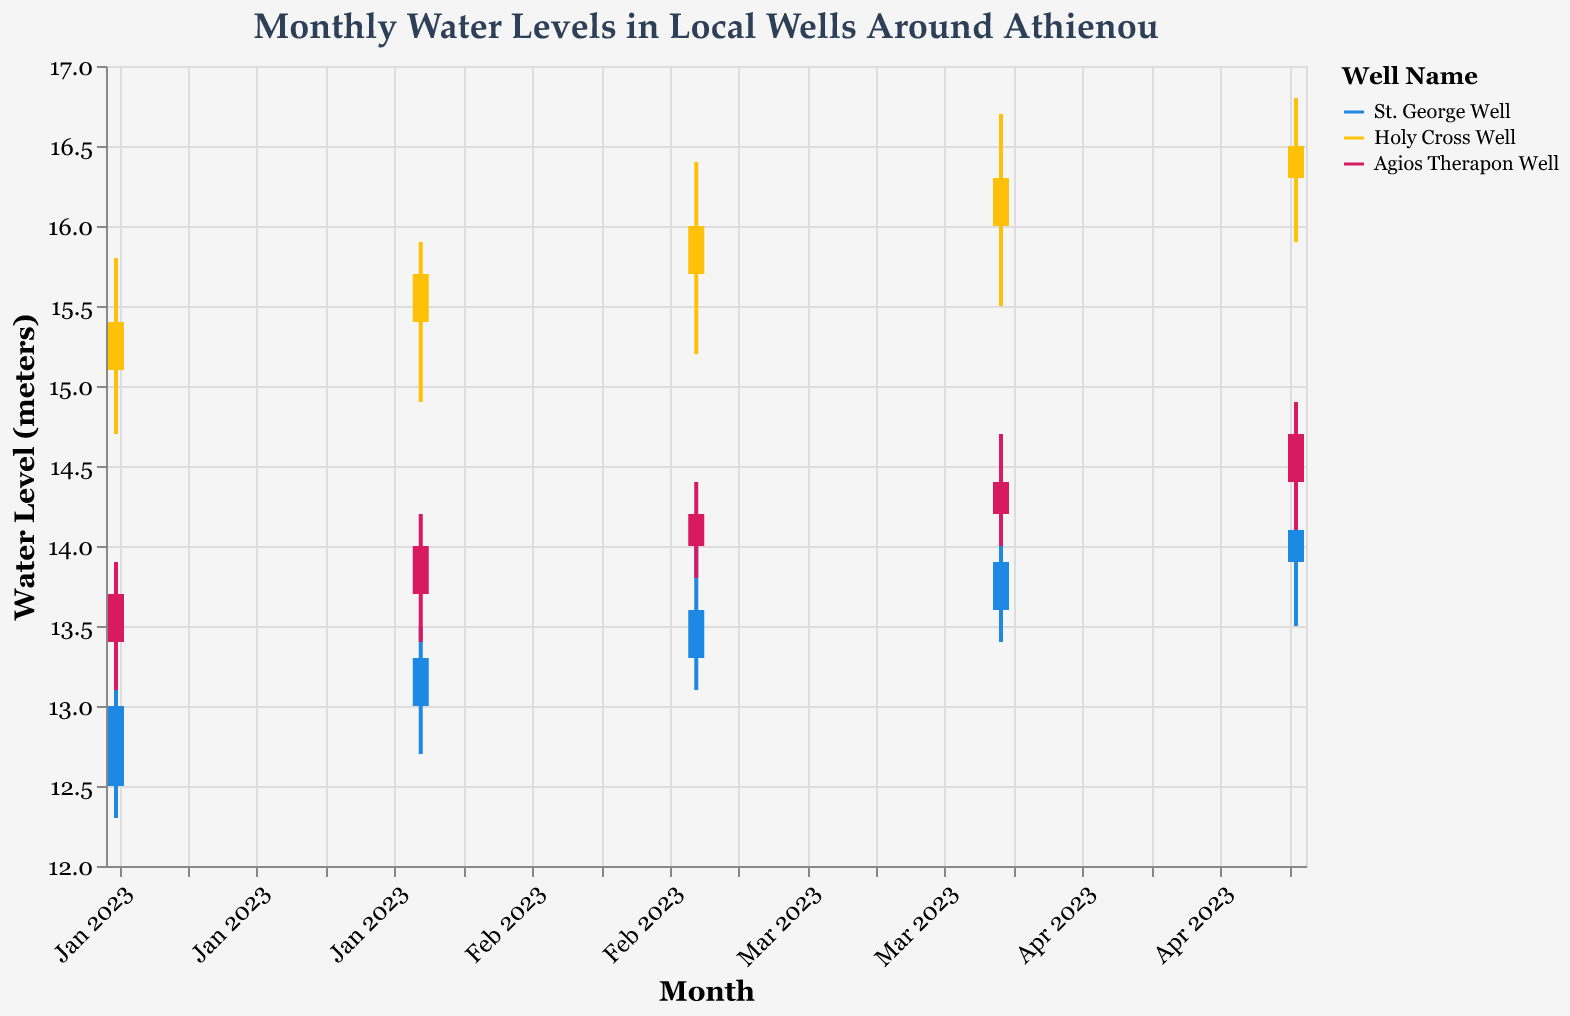What is the highest water level recorded at St. George Well in March 2023? The highest water level at St. George Well in March 2023 is indicated by the "High" value in the candlestick plot. By looking at the plot, the "High" value is recorded at 14.0 meters.
Answer: 14.0 meters Which well showed an increase in closing water levels each month from January to May 2023? By observing the "Close" values for each well from January to May 2023, we need to identify which well has a consistently rising trend. Holy Cross Well's closing values go from 15.4 (Jan), 15.7 (Feb), 16.0 (Mar), 16.3 (Apr), to 16.5 (May). This shows a monthly increase.
Answer: Holy Cross Well What was the water level range (difference between the high and low values) at Agios Therapon Well in April 2023? The water level range at Agios Therapon Well is calculated by subtracting the "Low" value from the "High" value in April 2023. The "High" value is 14.7 meters and the "Low" value is 14.0 meters, so the range is 14.7 - 14.0 = 0.7 meters.
Answer: 0.7 meters Which month recorded the lowest opening water level at St. George Well, and what was that level? By examining the "Open" values for St. George Well across the months, the lowest opening level is recorded in January 2023 at 12.5 meters.
Answer: January 2023, 12.5 meters Among the three wells, which one had the greatest difference between its highest and lowest water levels over the period from January to May 2023? To find the greatest difference, we need to look at the maximum and minimum "High" and "Low" values for all three wells over the period.
  - St. George Well: High = 14.4, Low = 12.3; Difference = 2.1
  - Holy Cross Well: High = 16.8, Low = 14.7; Difference = 2.1
  - Agios Therapon Well: High = 14.9, Low = 13.1; Difference = 1.8
Both St. George Well and Holy Cross Well have the greatest difference of 2.1 meters.
Answer: St. George Well and Holy Cross Well What was the average closing water level of Agios Therapon Well over the five months? To find the average, sum the "Close" values for Agios Therapon Well and divide by the number of months: (13.7 + 14.0 + 14.2 + 14.4 + 14.7) / 5 = (70.0 / 5) = 14.0 meters.
Answer: 14.0 meters During which month and at which well was the water level the lowest overall? To find the overall lowest water level, look at the "Low" values for all wells across months. The lowest value is 12.3 meters at St. George Well in January 2023.
Answer: January 2023, St. George Well 